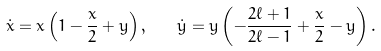<formula> <loc_0><loc_0><loc_500><loc_500>\dot { x } = x \left ( 1 - \frac { x } { 2 } + y \right ) , \quad \dot { y } = y \left ( - \frac { 2 \ell + 1 } { 2 \ell - 1 } + \frac { x } { 2 } - y \right ) .</formula> 